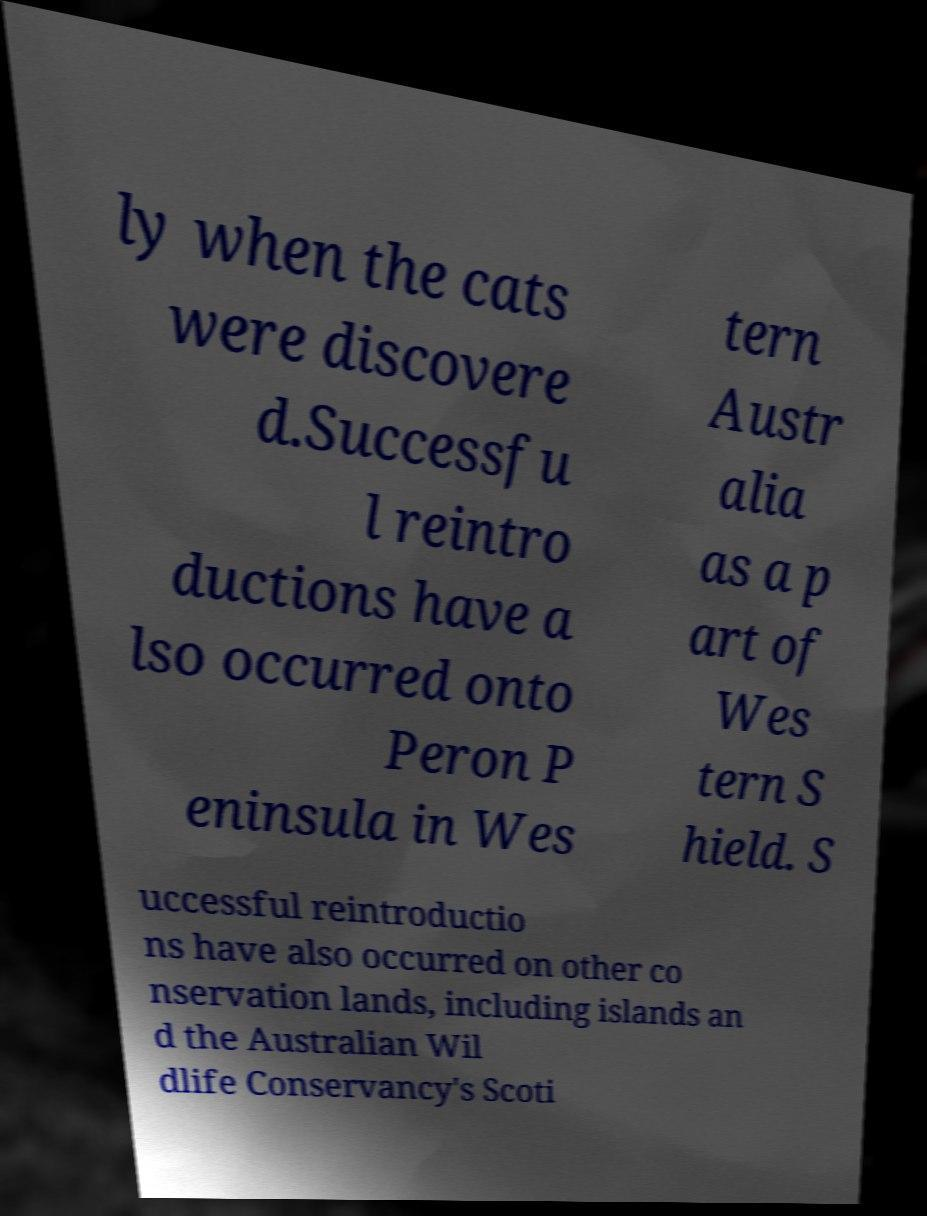Please identify and transcribe the text found in this image. ly when the cats were discovere d.Successfu l reintro ductions have a lso occurred onto Peron P eninsula in Wes tern Austr alia as a p art of Wes tern S hield. S uccessful reintroductio ns have also occurred on other co nservation lands, including islands an d the Australian Wil dlife Conservancy's Scoti 